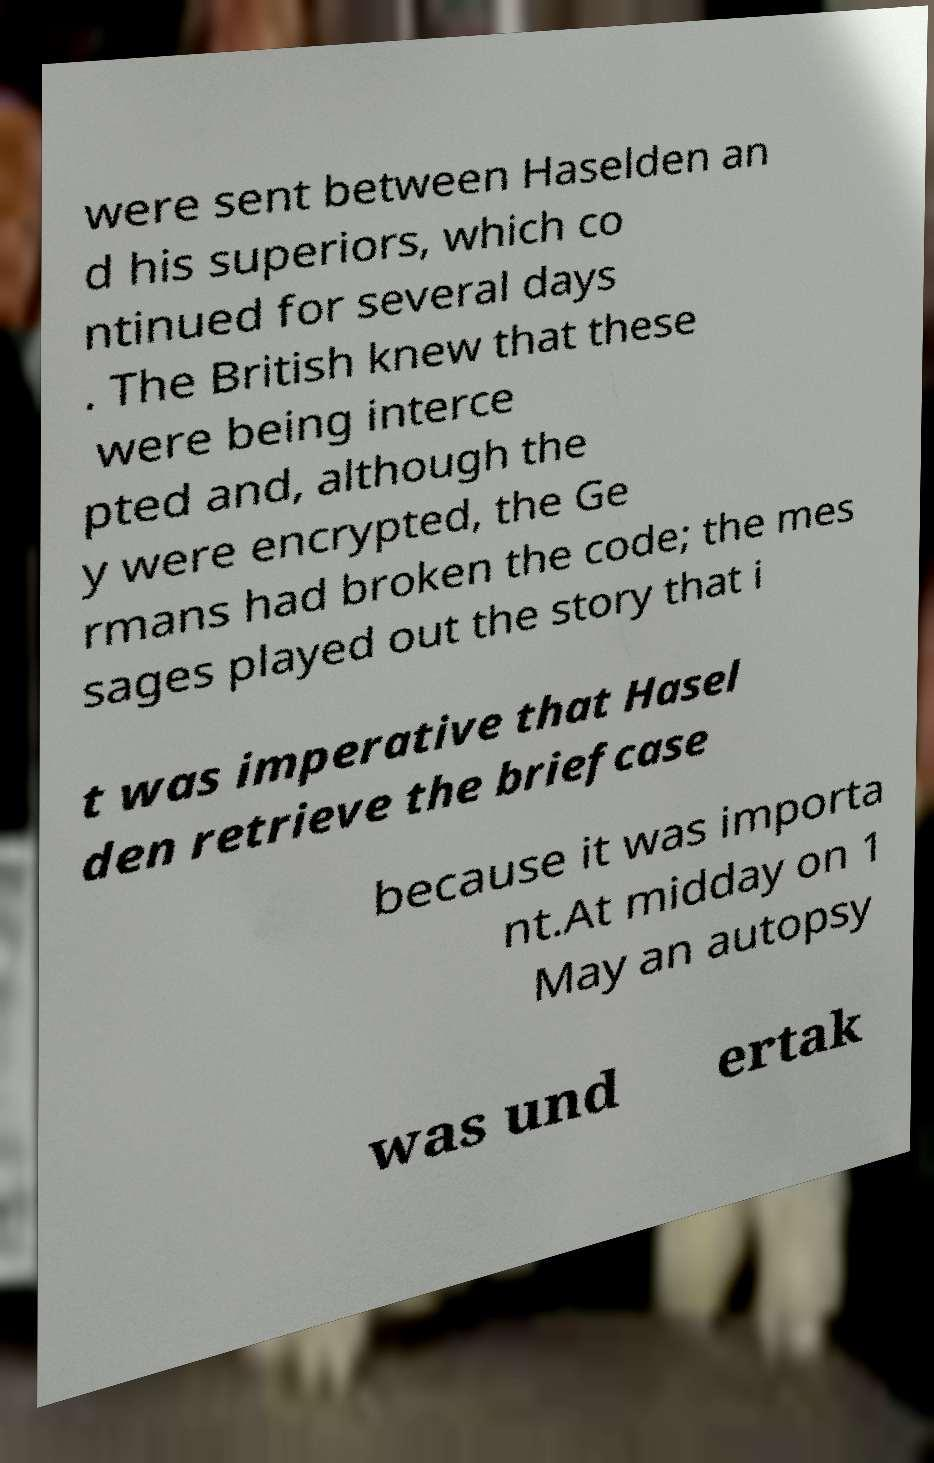Could you assist in decoding the text presented in this image and type it out clearly? were sent between Haselden an d his superiors, which co ntinued for several days . The British knew that these were being interce pted and, although the y were encrypted, the Ge rmans had broken the code; the mes sages played out the story that i t was imperative that Hasel den retrieve the briefcase because it was importa nt.At midday on 1 May an autopsy was und ertak 